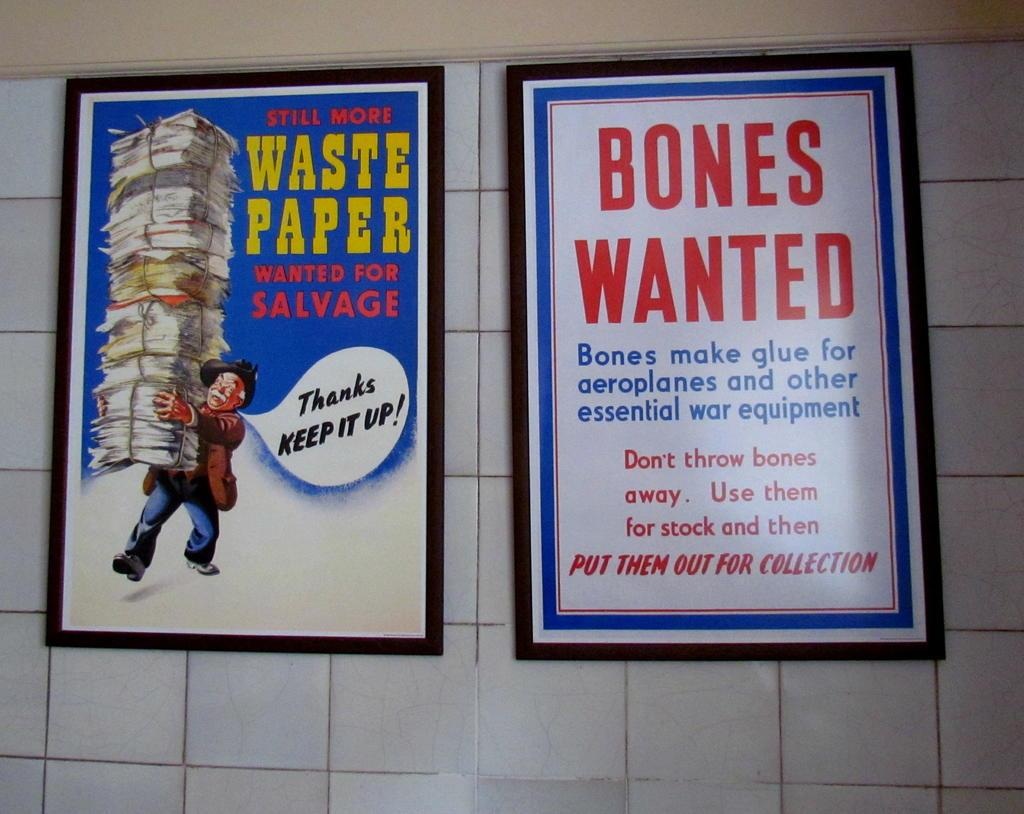<image>
Render a clear and concise summary of the photo. The two prints on the wall have funny comments about paper and bones. 